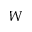Convert formula to latex. <formula><loc_0><loc_0><loc_500><loc_500>W</formula> 